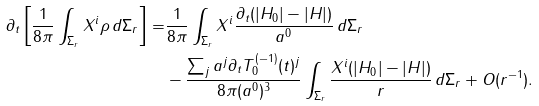<formula> <loc_0><loc_0><loc_500><loc_500>\partial _ { t } \left [ \frac { 1 } { 8 \pi } \int _ { \Sigma _ { r } } X ^ { i } \rho \, d \Sigma _ { r } \right ] = & \frac { 1 } { 8 \pi } \int _ { \Sigma _ { r } } X ^ { i } \frac { \partial _ { t } ( | H _ { 0 } | - | H | ) } { a ^ { 0 } } \, d \Sigma _ { r } \\ & - \frac { \sum _ { j } a ^ { j } \partial _ { t } T _ { 0 } ^ { ( - 1 ) } ( t ) ^ { j } } { 8 \pi ( a ^ { 0 } ) ^ { 3 } } \int _ { \Sigma _ { r } } \frac { X ^ { i } ( | H _ { 0 } | - | H | ) } { r } \, d \Sigma _ { r } + O ( r ^ { - 1 } ) .</formula> 